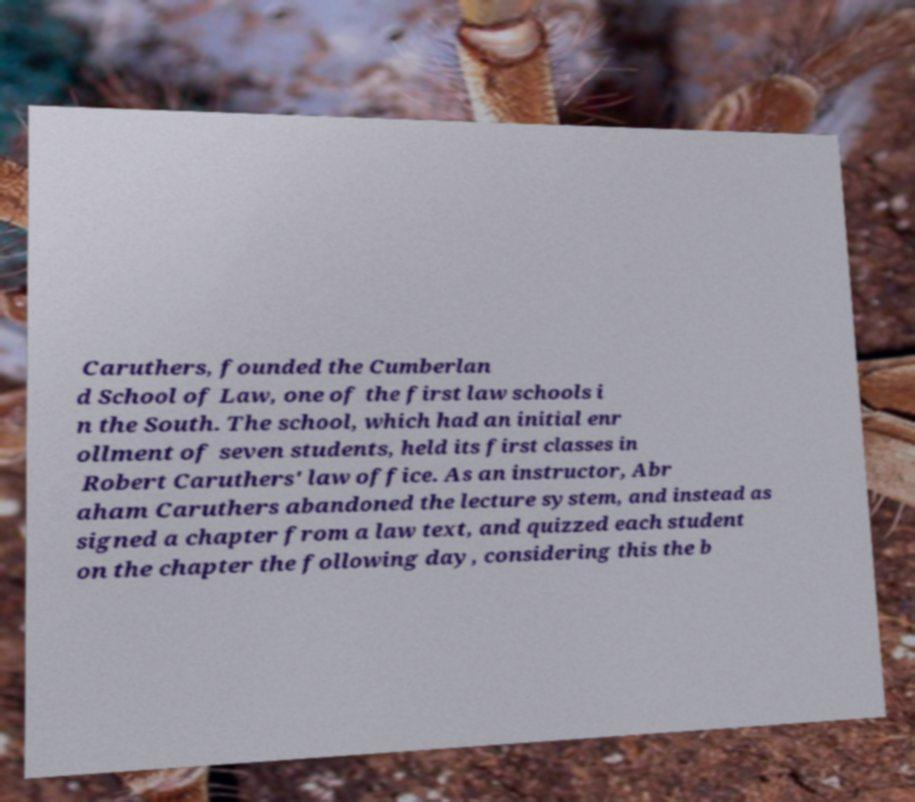Can you read and provide the text displayed in the image?This photo seems to have some interesting text. Can you extract and type it out for me? Caruthers, founded the Cumberlan d School of Law, one of the first law schools i n the South. The school, which had an initial enr ollment of seven students, held its first classes in Robert Caruthers' law office. As an instructor, Abr aham Caruthers abandoned the lecture system, and instead as signed a chapter from a law text, and quizzed each student on the chapter the following day, considering this the b 